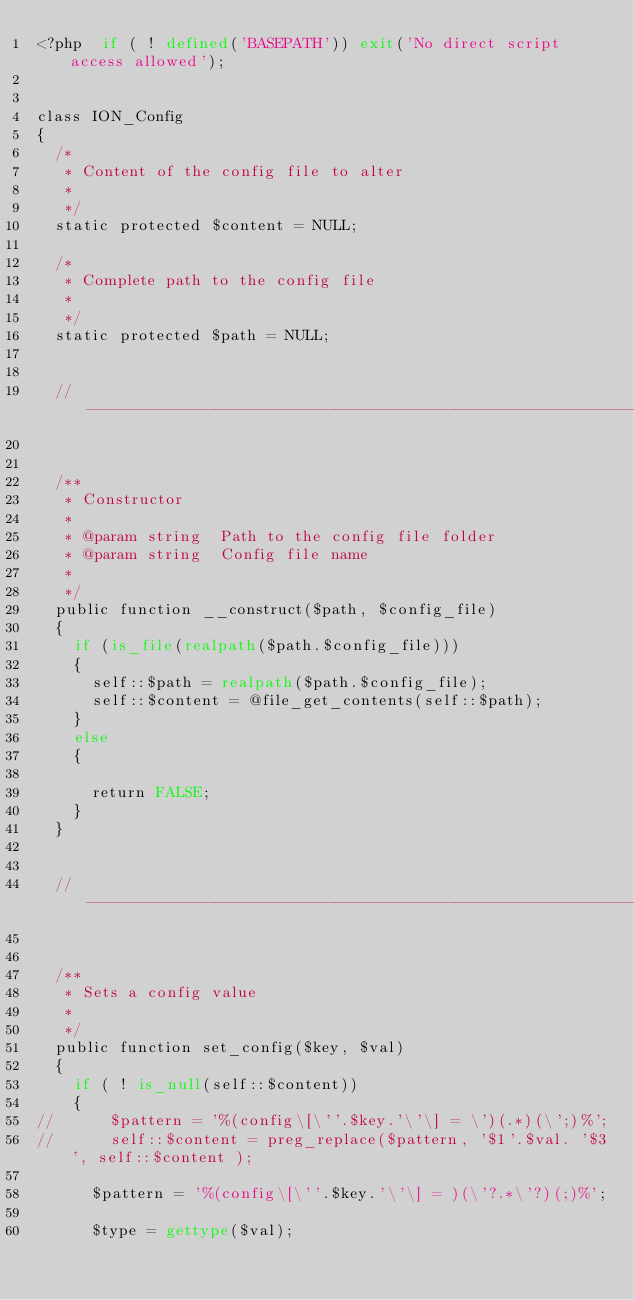<code> <loc_0><loc_0><loc_500><loc_500><_PHP_><?php  if ( ! defined('BASEPATH')) exit('No direct script access allowed');


class ION_Config
{
	/*
	 * Content of the config file to alter
	 *
	 */
	static protected $content = NULL;
	
	/*
	 * Complete path to the config file
	 *
	 */
	static protected $path = NULL;


	// --------------------------------------------------------------------

	
	/**
	 * Constructor
	 *
	 * @param	string  Path to the config file folder
	 * @param	string  Config file name
	 *
	 */
	public function __construct($path, $config_file)
	{
		if (is_file(realpath($path.$config_file)))
		{
			self::$path = realpath($path.$config_file);
			self::$content = @file_get_contents(self::$path);
		}
		else
		{
		
			return FALSE;
		}
	}
	

	// --------------------------------------------------------------------


	/**
	 * Sets a config value
	 *
	 */
	public function set_config($key, $val)
	{
		if ( ! is_null(self::$content))
		{
//			$pattern = '%(config\[\''.$key.'\'\] = \')(.*)(\';)%';
//			self::$content = preg_replace($pattern, '$1'.$val. '$3', self::$content );

			$pattern = '%(config\[\''.$key.'\'\] = )(\'?.*\'?)(;)%';

			$type = gettype($val);
			</code> 